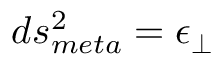Convert formula to latex. <formula><loc_0><loc_0><loc_500><loc_500>d s _ { m e t a } ^ { 2 } = \epsilon _ { \perp }</formula> 